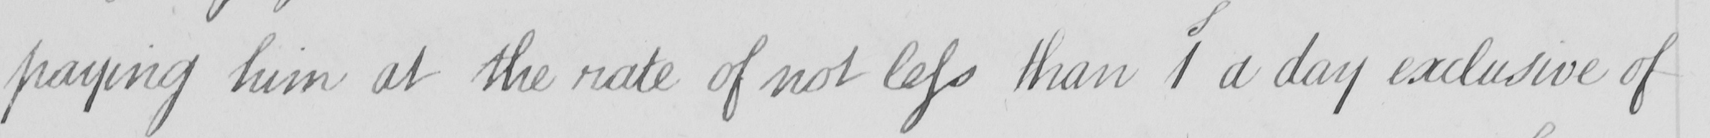What does this handwritten line say? paying him at the rate of not less than 1S a day exclusive of 